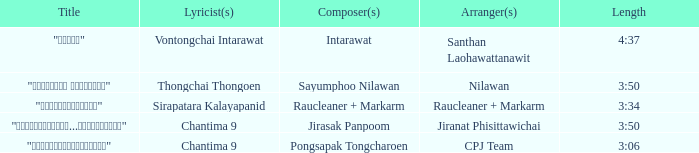Who was the arranger of "ขอโทษ"? Santhan Laohawattanawit. Would you mind parsing the complete table? {'header': ['Title', 'Lyricist(s)', 'Composer(s)', 'Arranger(s)', 'Length'], 'rows': [['"ขอโทษ"', 'Vontongchai Intarawat', 'Intarawat', 'Santhan Laohawattanawit', '4:37'], ['"เลือกลืม เลือกจำ"', 'Thongchai Thongoen', 'Sayumphoo Nilawan', 'Nilawan', '3:50'], ['"แค่อยากให้รู้"', 'Sirapatara Kalayapanid', 'Raucleaner + Markarm', 'Raucleaner + Markarm', '3:34'], ['"เรายังรักกัน...ไม่ใช่เหรอ"', 'Chantima 9', 'Jirasak Panpoom', 'Jiranat Phisittawichai', '3:50'], ['"นางฟ้าตาชั้นเดียว"', 'Chantima 9', 'Pongsapak Tongcharoen', 'CPJ Team', '3:06']]} 